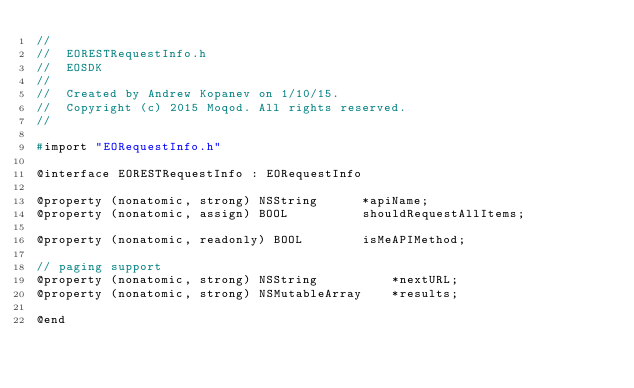Convert code to text. <code><loc_0><loc_0><loc_500><loc_500><_C_>//
//  EORESTRequestInfo.h
//  EOSDK
//
//  Created by Andrew Kopanev on 1/10/15.
//  Copyright (c) 2015 Moqod. All rights reserved.
//

#import "EORequestInfo.h"

@interface EORESTRequestInfo : EORequestInfo

@property (nonatomic, strong) NSString		*apiName;
@property (nonatomic, assign) BOOL			shouldRequestAllItems;

@property (nonatomic, readonly) BOOL		isMeAPIMethod;

// paging support
@property (nonatomic, strong) NSString			*nextURL;
@property (nonatomic, strong) NSMutableArray	*results;

@end
</code> 